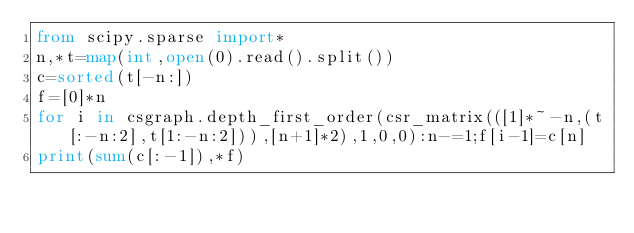Convert code to text. <code><loc_0><loc_0><loc_500><loc_500><_Python_>from scipy.sparse import*
n,*t=map(int,open(0).read().split())
c=sorted(t[-n:])
f=[0]*n
for i in csgraph.depth_first_order(csr_matrix(([1]*~-n,(t[:-n:2],t[1:-n:2])),[n+1]*2),1,0,0):n-=1;f[i-1]=c[n]
print(sum(c[:-1]),*f)</code> 